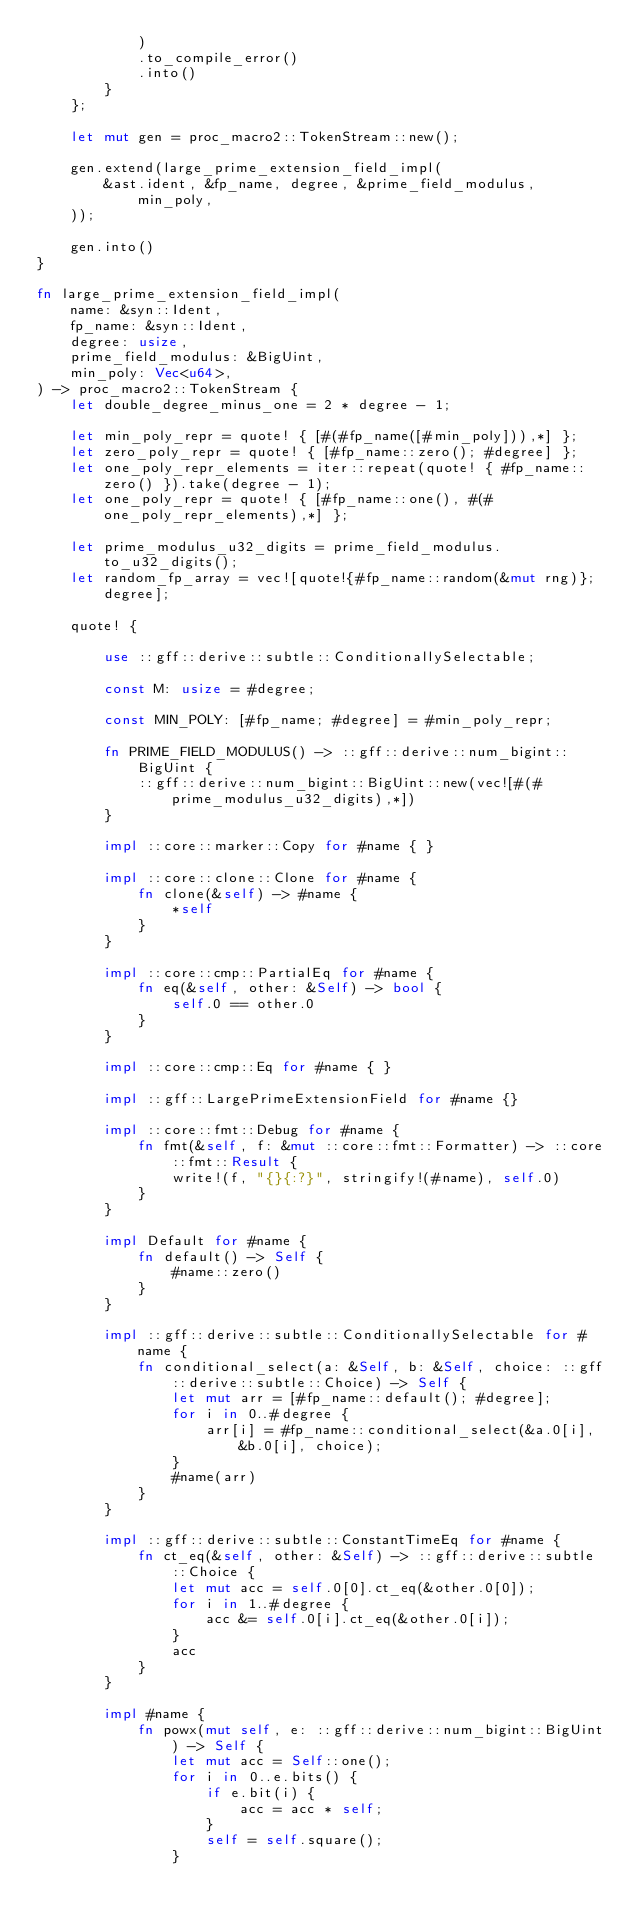<code> <loc_0><loc_0><loc_500><loc_500><_Rust_>            )
            .to_compile_error()
            .into()
        }
    };

    let mut gen = proc_macro2::TokenStream::new();

    gen.extend(large_prime_extension_field_impl(
        &ast.ident, &fp_name, degree, &prime_field_modulus, min_poly,
    ));

    gen.into()
}

fn large_prime_extension_field_impl(
    name: &syn::Ident,
    fp_name: &syn::Ident,
    degree: usize,
    prime_field_modulus: &BigUint,
    min_poly: Vec<u64>,
) -> proc_macro2::TokenStream {
    let double_degree_minus_one = 2 * degree - 1;

    let min_poly_repr = quote! { [#(#fp_name([#min_poly])),*] };
    let zero_poly_repr = quote! { [#fp_name::zero(); #degree] };
    let one_poly_repr_elements = iter::repeat(quote! { #fp_name::zero() }).take(degree - 1);
    let one_poly_repr = quote! { [#fp_name::one(), #(#one_poly_repr_elements),*] };

    let prime_modulus_u32_digits = prime_field_modulus.to_u32_digits();
    let random_fp_array = vec![quote!{#fp_name::random(&mut rng)}; degree];

    quote! {

        use ::gff::derive::subtle::ConditionallySelectable;

        const M: usize = #degree;

        const MIN_POLY: [#fp_name; #degree] = #min_poly_repr;

        fn PRIME_FIELD_MODULUS() -> ::gff::derive::num_bigint::BigUint {
            ::gff::derive::num_bigint::BigUint::new(vec![#(#prime_modulus_u32_digits),*])
        } 

        impl ::core::marker::Copy for #name { }

        impl ::core::clone::Clone for #name {
            fn clone(&self) -> #name {
                *self
            }
        }

        impl ::core::cmp::PartialEq for #name {
            fn eq(&self, other: &Self) -> bool {
                self.0 == other.0
            }
        }

        impl ::core::cmp::Eq for #name { }

        impl ::gff::LargePrimeExtensionField for #name {}

        impl ::core::fmt::Debug for #name {
            fn fmt(&self, f: &mut ::core::fmt::Formatter) -> ::core::fmt::Result {
                write!(f, "{}{:?}", stringify!(#name), self.0)
            }
        }

        impl Default for #name {
            fn default() -> Self {
                #name::zero()
            }
        }

        impl ::gff::derive::subtle::ConditionallySelectable for #name {
            fn conditional_select(a: &Self, b: &Self, choice: ::gff::derive::subtle::Choice) -> Self {
                let mut arr = [#fp_name::default(); #degree];
                for i in 0..#degree {
                    arr[i] = #fp_name::conditional_select(&a.0[i], &b.0[i], choice);
                }
                #name(arr)
            }
        }

        impl ::gff::derive::subtle::ConstantTimeEq for #name {
            fn ct_eq(&self, other: &Self) -> ::gff::derive::subtle::Choice {
                let mut acc = self.0[0].ct_eq(&other.0[0]);
                for i in 1..#degree {
                    acc &= self.0[i].ct_eq(&other.0[i]);
                }
                acc
            }
        }

        impl #name {
            fn powx(mut self, e: ::gff::derive::num_bigint::BigUint) -> Self {
                let mut acc = Self::one();
                for i in 0..e.bits() {
                    if e.bit(i) {
                        acc = acc * self;
                    }
                    self = self.square();
                }</code> 